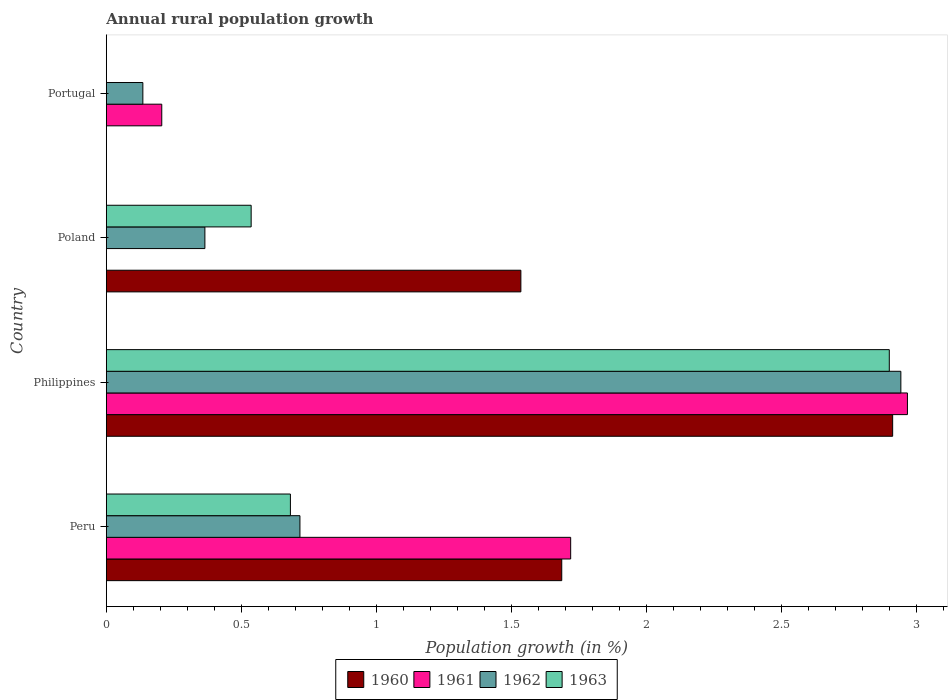How many different coloured bars are there?
Your answer should be very brief. 4. How many groups of bars are there?
Ensure brevity in your answer.  4. Are the number of bars per tick equal to the number of legend labels?
Provide a short and direct response. No. Are the number of bars on each tick of the Y-axis equal?
Provide a succinct answer. No. How many bars are there on the 4th tick from the bottom?
Provide a short and direct response. 2. What is the percentage of rural population growth in 1961 in Philippines?
Your answer should be compact. 2.97. Across all countries, what is the maximum percentage of rural population growth in 1962?
Your answer should be compact. 2.94. Across all countries, what is the minimum percentage of rural population growth in 1960?
Your response must be concise. 0. In which country was the percentage of rural population growth in 1962 maximum?
Your response must be concise. Philippines. What is the total percentage of rural population growth in 1960 in the graph?
Give a very brief answer. 6.13. What is the difference between the percentage of rural population growth in 1962 in Philippines and that in Poland?
Offer a very short reply. 2.58. What is the difference between the percentage of rural population growth in 1960 in Poland and the percentage of rural population growth in 1962 in Peru?
Provide a succinct answer. 0.82. What is the average percentage of rural population growth in 1962 per country?
Ensure brevity in your answer.  1.04. What is the difference between the percentage of rural population growth in 1963 and percentage of rural population growth in 1962 in Philippines?
Your answer should be very brief. -0.04. In how many countries, is the percentage of rural population growth in 1963 greater than 1.6 %?
Give a very brief answer. 1. What is the ratio of the percentage of rural population growth in 1963 in Philippines to that in Poland?
Your answer should be compact. 5.41. What is the difference between the highest and the second highest percentage of rural population growth in 1962?
Make the answer very short. 2.23. What is the difference between the highest and the lowest percentage of rural population growth in 1962?
Provide a succinct answer. 2.81. Is the sum of the percentage of rural population growth in 1962 in Peru and Philippines greater than the maximum percentage of rural population growth in 1961 across all countries?
Keep it short and to the point. Yes. How many bars are there?
Provide a succinct answer. 13. Are the values on the major ticks of X-axis written in scientific E-notation?
Make the answer very short. No. Does the graph contain grids?
Offer a very short reply. No. What is the title of the graph?
Your answer should be very brief. Annual rural population growth. What is the label or title of the X-axis?
Your answer should be compact. Population growth (in %). What is the Population growth (in %) of 1960 in Peru?
Offer a very short reply. 1.69. What is the Population growth (in %) in 1961 in Peru?
Make the answer very short. 1.72. What is the Population growth (in %) in 1962 in Peru?
Your answer should be very brief. 0.72. What is the Population growth (in %) of 1963 in Peru?
Your response must be concise. 0.68. What is the Population growth (in %) of 1960 in Philippines?
Offer a terse response. 2.91. What is the Population growth (in %) in 1961 in Philippines?
Ensure brevity in your answer.  2.97. What is the Population growth (in %) of 1962 in Philippines?
Offer a very short reply. 2.94. What is the Population growth (in %) in 1963 in Philippines?
Provide a succinct answer. 2.9. What is the Population growth (in %) in 1960 in Poland?
Offer a terse response. 1.53. What is the Population growth (in %) of 1962 in Poland?
Provide a short and direct response. 0.36. What is the Population growth (in %) of 1963 in Poland?
Provide a short and direct response. 0.54. What is the Population growth (in %) in 1961 in Portugal?
Make the answer very short. 0.21. What is the Population growth (in %) of 1962 in Portugal?
Offer a very short reply. 0.14. What is the Population growth (in %) in 1963 in Portugal?
Provide a succinct answer. 0. Across all countries, what is the maximum Population growth (in %) of 1960?
Offer a very short reply. 2.91. Across all countries, what is the maximum Population growth (in %) of 1961?
Offer a terse response. 2.97. Across all countries, what is the maximum Population growth (in %) in 1962?
Your answer should be very brief. 2.94. Across all countries, what is the maximum Population growth (in %) in 1963?
Provide a succinct answer. 2.9. Across all countries, what is the minimum Population growth (in %) of 1960?
Your answer should be compact. 0. Across all countries, what is the minimum Population growth (in %) in 1961?
Make the answer very short. 0. Across all countries, what is the minimum Population growth (in %) of 1962?
Ensure brevity in your answer.  0.14. What is the total Population growth (in %) in 1960 in the graph?
Your response must be concise. 6.13. What is the total Population growth (in %) in 1961 in the graph?
Your response must be concise. 4.89. What is the total Population growth (in %) in 1962 in the graph?
Your response must be concise. 4.16. What is the total Population growth (in %) of 1963 in the graph?
Offer a terse response. 4.12. What is the difference between the Population growth (in %) in 1960 in Peru and that in Philippines?
Offer a very short reply. -1.23. What is the difference between the Population growth (in %) of 1961 in Peru and that in Philippines?
Provide a short and direct response. -1.25. What is the difference between the Population growth (in %) of 1962 in Peru and that in Philippines?
Provide a short and direct response. -2.23. What is the difference between the Population growth (in %) of 1963 in Peru and that in Philippines?
Provide a short and direct response. -2.22. What is the difference between the Population growth (in %) in 1960 in Peru and that in Poland?
Ensure brevity in your answer.  0.15. What is the difference between the Population growth (in %) in 1962 in Peru and that in Poland?
Offer a terse response. 0.35. What is the difference between the Population growth (in %) of 1963 in Peru and that in Poland?
Offer a terse response. 0.15. What is the difference between the Population growth (in %) of 1961 in Peru and that in Portugal?
Your answer should be very brief. 1.51. What is the difference between the Population growth (in %) of 1962 in Peru and that in Portugal?
Make the answer very short. 0.58. What is the difference between the Population growth (in %) of 1960 in Philippines and that in Poland?
Your answer should be compact. 1.38. What is the difference between the Population growth (in %) in 1962 in Philippines and that in Poland?
Offer a terse response. 2.58. What is the difference between the Population growth (in %) of 1963 in Philippines and that in Poland?
Offer a very short reply. 2.36. What is the difference between the Population growth (in %) in 1961 in Philippines and that in Portugal?
Make the answer very short. 2.76. What is the difference between the Population growth (in %) in 1962 in Philippines and that in Portugal?
Keep it short and to the point. 2.81. What is the difference between the Population growth (in %) in 1962 in Poland and that in Portugal?
Keep it short and to the point. 0.23. What is the difference between the Population growth (in %) of 1960 in Peru and the Population growth (in %) of 1961 in Philippines?
Your answer should be very brief. -1.28. What is the difference between the Population growth (in %) in 1960 in Peru and the Population growth (in %) in 1962 in Philippines?
Offer a terse response. -1.26. What is the difference between the Population growth (in %) in 1960 in Peru and the Population growth (in %) in 1963 in Philippines?
Offer a very short reply. -1.21. What is the difference between the Population growth (in %) of 1961 in Peru and the Population growth (in %) of 1962 in Philippines?
Offer a terse response. -1.22. What is the difference between the Population growth (in %) in 1961 in Peru and the Population growth (in %) in 1963 in Philippines?
Offer a very short reply. -1.18. What is the difference between the Population growth (in %) of 1962 in Peru and the Population growth (in %) of 1963 in Philippines?
Make the answer very short. -2.18. What is the difference between the Population growth (in %) in 1960 in Peru and the Population growth (in %) in 1962 in Poland?
Your answer should be very brief. 1.32. What is the difference between the Population growth (in %) of 1960 in Peru and the Population growth (in %) of 1963 in Poland?
Give a very brief answer. 1.15. What is the difference between the Population growth (in %) of 1961 in Peru and the Population growth (in %) of 1962 in Poland?
Offer a very short reply. 1.35. What is the difference between the Population growth (in %) of 1961 in Peru and the Population growth (in %) of 1963 in Poland?
Provide a short and direct response. 1.18. What is the difference between the Population growth (in %) of 1962 in Peru and the Population growth (in %) of 1963 in Poland?
Offer a terse response. 0.18. What is the difference between the Population growth (in %) in 1960 in Peru and the Population growth (in %) in 1961 in Portugal?
Keep it short and to the point. 1.48. What is the difference between the Population growth (in %) in 1960 in Peru and the Population growth (in %) in 1962 in Portugal?
Provide a short and direct response. 1.55. What is the difference between the Population growth (in %) of 1961 in Peru and the Population growth (in %) of 1962 in Portugal?
Give a very brief answer. 1.58. What is the difference between the Population growth (in %) in 1960 in Philippines and the Population growth (in %) in 1962 in Poland?
Offer a terse response. 2.55. What is the difference between the Population growth (in %) in 1960 in Philippines and the Population growth (in %) in 1963 in Poland?
Make the answer very short. 2.38. What is the difference between the Population growth (in %) in 1961 in Philippines and the Population growth (in %) in 1962 in Poland?
Your answer should be compact. 2.6. What is the difference between the Population growth (in %) of 1961 in Philippines and the Population growth (in %) of 1963 in Poland?
Your response must be concise. 2.43. What is the difference between the Population growth (in %) in 1962 in Philippines and the Population growth (in %) in 1963 in Poland?
Keep it short and to the point. 2.41. What is the difference between the Population growth (in %) of 1960 in Philippines and the Population growth (in %) of 1961 in Portugal?
Provide a short and direct response. 2.71. What is the difference between the Population growth (in %) of 1960 in Philippines and the Population growth (in %) of 1962 in Portugal?
Your answer should be very brief. 2.78. What is the difference between the Population growth (in %) of 1961 in Philippines and the Population growth (in %) of 1962 in Portugal?
Offer a terse response. 2.83. What is the difference between the Population growth (in %) in 1960 in Poland and the Population growth (in %) in 1961 in Portugal?
Make the answer very short. 1.33. What is the difference between the Population growth (in %) of 1960 in Poland and the Population growth (in %) of 1962 in Portugal?
Ensure brevity in your answer.  1.4. What is the average Population growth (in %) of 1960 per country?
Make the answer very short. 1.53. What is the average Population growth (in %) in 1961 per country?
Your answer should be very brief. 1.22. What is the average Population growth (in %) in 1962 per country?
Make the answer very short. 1.04. What is the average Population growth (in %) in 1963 per country?
Provide a short and direct response. 1.03. What is the difference between the Population growth (in %) in 1960 and Population growth (in %) in 1961 in Peru?
Ensure brevity in your answer.  -0.03. What is the difference between the Population growth (in %) of 1960 and Population growth (in %) of 1962 in Peru?
Give a very brief answer. 0.97. What is the difference between the Population growth (in %) in 1960 and Population growth (in %) in 1963 in Peru?
Your response must be concise. 1. What is the difference between the Population growth (in %) of 1961 and Population growth (in %) of 1962 in Peru?
Provide a short and direct response. 1. What is the difference between the Population growth (in %) of 1961 and Population growth (in %) of 1963 in Peru?
Make the answer very short. 1.04. What is the difference between the Population growth (in %) in 1962 and Population growth (in %) in 1963 in Peru?
Provide a succinct answer. 0.04. What is the difference between the Population growth (in %) in 1960 and Population growth (in %) in 1961 in Philippines?
Give a very brief answer. -0.05. What is the difference between the Population growth (in %) in 1960 and Population growth (in %) in 1962 in Philippines?
Make the answer very short. -0.03. What is the difference between the Population growth (in %) in 1960 and Population growth (in %) in 1963 in Philippines?
Offer a very short reply. 0.01. What is the difference between the Population growth (in %) of 1961 and Population growth (in %) of 1962 in Philippines?
Make the answer very short. 0.02. What is the difference between the Population growth (in %) of 1961 and Population growth (in %) of 1963 in Philippines?
Offer a very short reply. 0.07. What is the difference between the Population growth (in %) in 1962 and Population growth (in %) in 1963 in Philippines?
Give a very brief answer. 0.04. What is the difference between the Population growth (in %) in 1960 and Population growth (in %) in 1962 in Poland?
Your answer should be compact. 1.17. What is the difference between the Population growth (in %) in 1960 and Population growth (in %) in 1963 in Poland?
Offer a very short reply. 1. What is the difference between the Population growth (in %) in 1962 and Population growth (in %) in 1963 in Poland?
Make the answer very short. -0.17. What is the difference between the Population growth (in %) of 1961 and Population growth (in %) of 1962 in Portugal?
Your answer should be compact. 0.07. What is the ratio of the Population growth (in %) of 1960 in Peru to that in Philippines?
Give a very brief answer. 0.58. What is the ratio of the Population growth (in %) of 1961 in Peru to that in Philippines?
Offer a terse response. 0.58. What is the ratio of the Population growth (in %) of 1962 in Peru to that in Philippines?
Your answer should be very brief. 0.24. What is the ratio of the Population growth (in %) of 1963 in Peru to that in Philippines?
Your answer should be very brief. 0.24. What is the ratio of the Population growth (in %) of 1960 in Peru to that in Poland?
Your answer should be compact. 1.1. What is the ratio of the Population growth (in %) in 1962 in Peru to that in Poland?
Your answer should be compact. 1.96. What is the ratio of the Population growth (in %) in 1963 in Peru to that in Poland?
Offer a very short reply. 1.27. What is the ratio of the Population growth (in %) of 1961 in Peru to that in Portugal?
Your answer should be compact. 8.38. What is the ratio of the Population growth (in %) in 1962 in Peru to that in Portugal?
Your answer should be very brief. 5.3. What is the ratio of the Population growth (in %) in 1960 in Philippines to that in Poland?
Provide a succinct answer. 1.9. What is the ratio of the Population growth (in %) in 1962 in Philippines to that in Poland?
Offer a very short reply. 8.06. What is the ratio of the Population growth (in %) in 1963 in Philippines to that in Poland?
Your answer should be compact. 5.41. What is the ratio of the Population growth (in %) of 1961 in Philippines to that in Portugal?
Offer a very short reply. 14.45. What is the ratio of the Population growth (in %) of 1962 in Philippines to that in Portugal?
Your response must be concise. 21.75. What is the ratio of the Population growth (in %) of 1962 in Poland to that in Portugal?
Provide a succinct answer. 2.7. What is the difference between the highest and the second highest Population growth (in %) of 1960?
Provide a short and direct response. 1.23. What is the difference between the highest and the second highest Population growth (in %) of 1961?
Your answer should be very brief. 1.25. What is the difference between the highest and the second highest Population growth (in %) in 1962?
Your answer should be very brief. 2.23. What is the difference between the highest and the second highest Population growth (in %) in 1963?
Provide a succinct answer. 2.22. What is the difference between the highest and the lowest Population growth (in %) of 1960?
Give a very brief answer. 2.91. What is the difference between the highest and the lowest Population growth (in %) in 1961?
Make the answer very short. 2.97. What is the difference between the highest and the lowest Population growth (in %) in 1962?
Ensure brevity in your answer.  2.81. What is the difference between the highest and the lowest Population growth (in %) in 1963?
Your response must be concise. 2.9. 